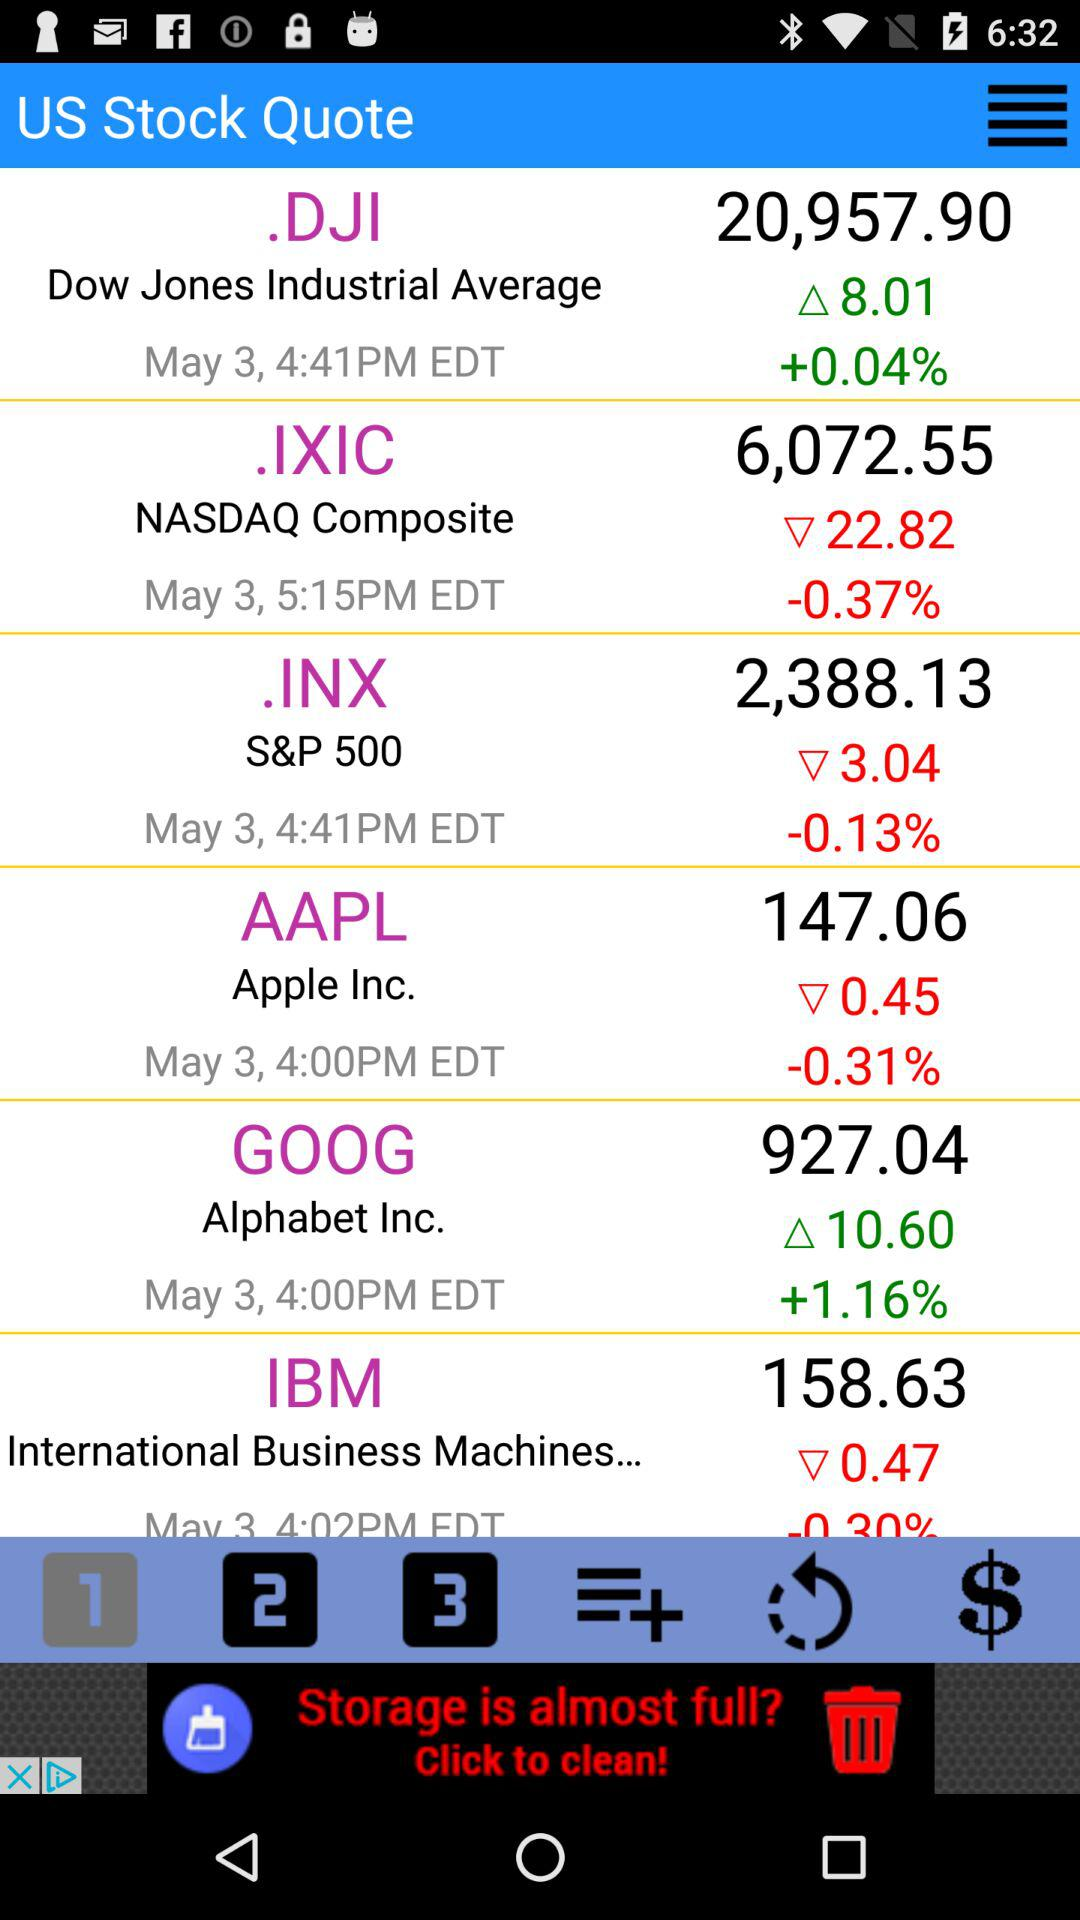What is the stock price of AAPL? The stock price is 147.06. 